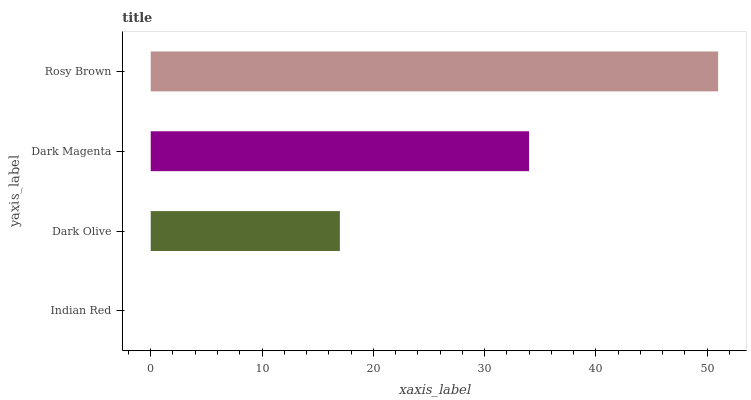Is Indian Red the minimum?
Answer yes or no. Yes. Is Rosy Brown the maximum?
Answer yes or no. Yes. Is Dark Olive the minimum?
Answer yes or no. No. Is Dark Olive the maximum?
Answer yes or no. No. Is Dark Olive greater than Indian Red?
Answer yes or no. Yes. Is Indian Red less than Dark Olive?
Answer yes or no. Yes. Is Indian Red greater than Dark Olive?
Answer yes or no. No. Is Dark Olive less than Indian Red?
Answer yes or no. No. Is Dark Magenta the high median?
Answer yes or no. Yes. Is Dark Olive the low median?
Answer yes or no. Yes. Is Dark Olive the high median?
Answer yes or no. No. Is Dark Magenta the low median?
Answer yes or no. No. 